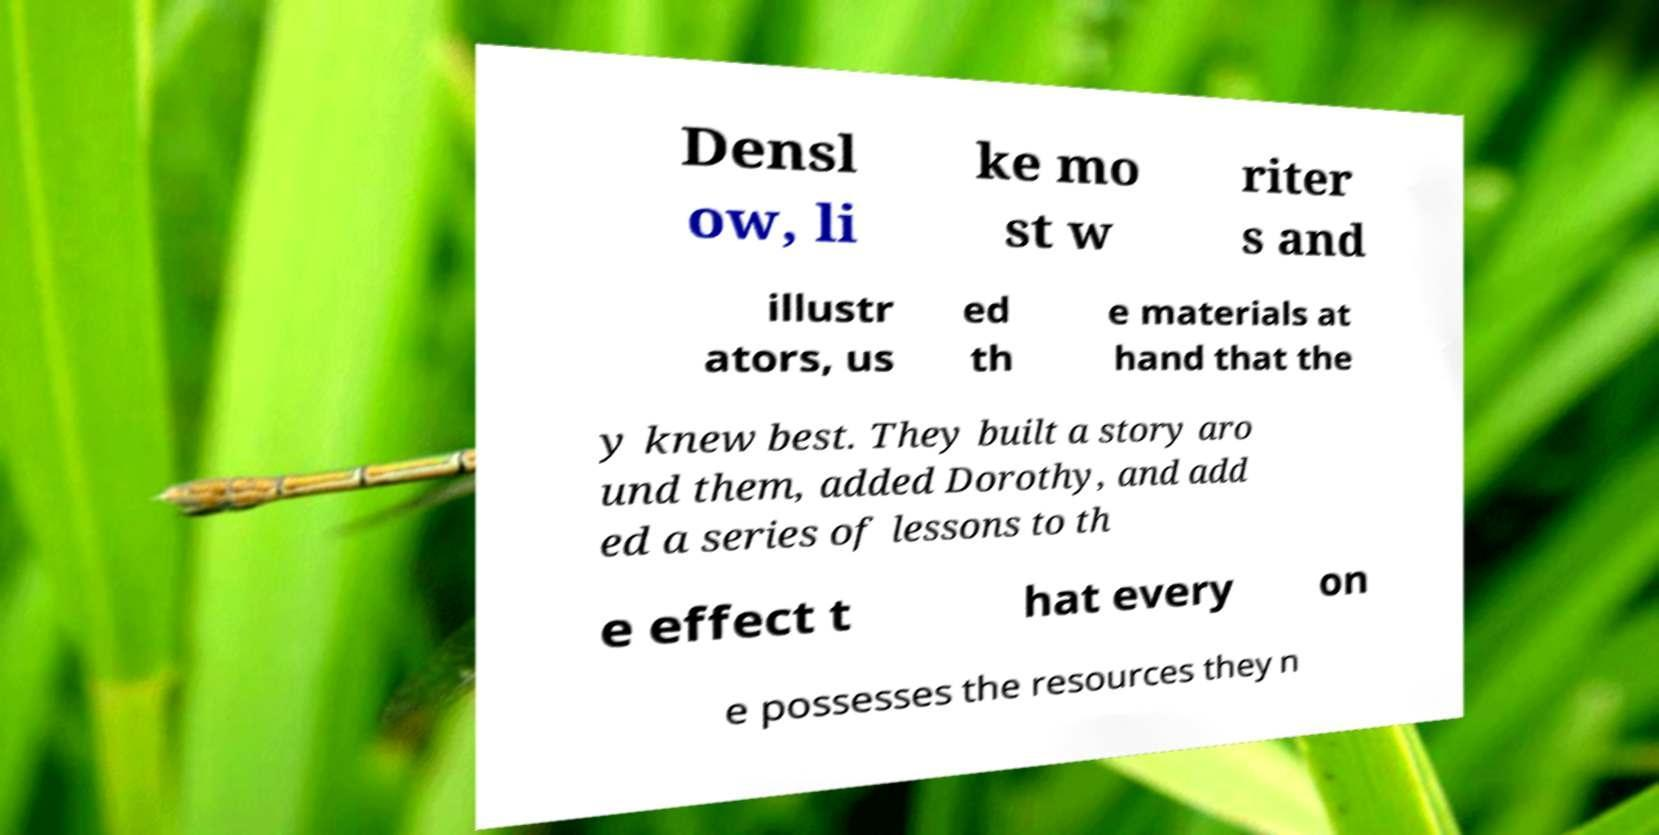Please identify and transcribe the text found in this image. Densl ow, li ke mo st w riter s and illustr ators, us ed th e materials at hand that the y knew best. They built a story aro und them, added Dorothy, and add ed a series of lessons to th e effect t hat every on e possesses the resources they n 